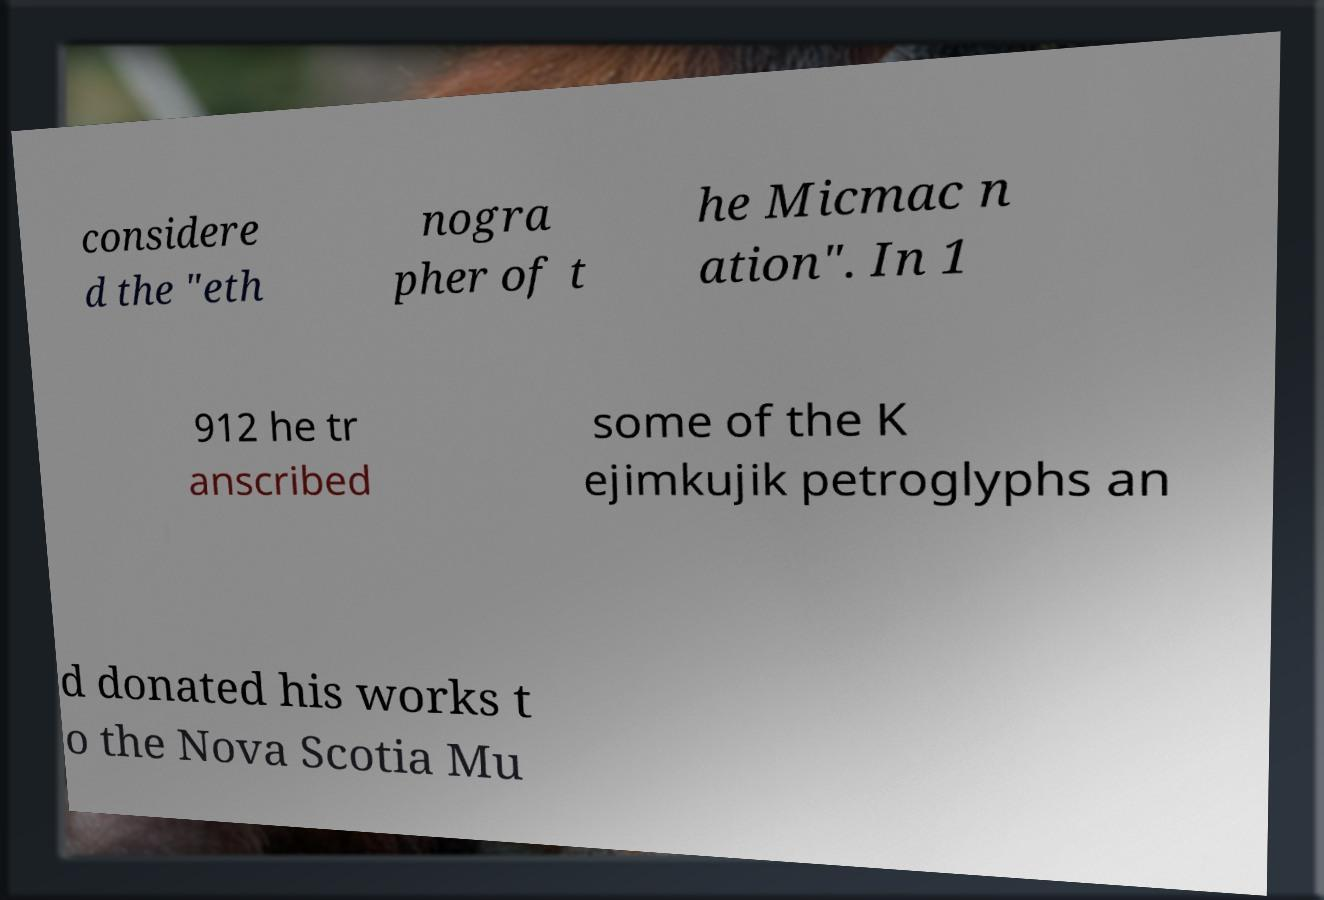There's text embedded in this image that I need extracted. Can you transcribe it verbatim? considere d the "eth nogra pher of t he Micmac n ation". In 1 912 he tr anscribed some of the K ejimkujik petroglyphs an d donated his works t o the Nova Scotia Mu 